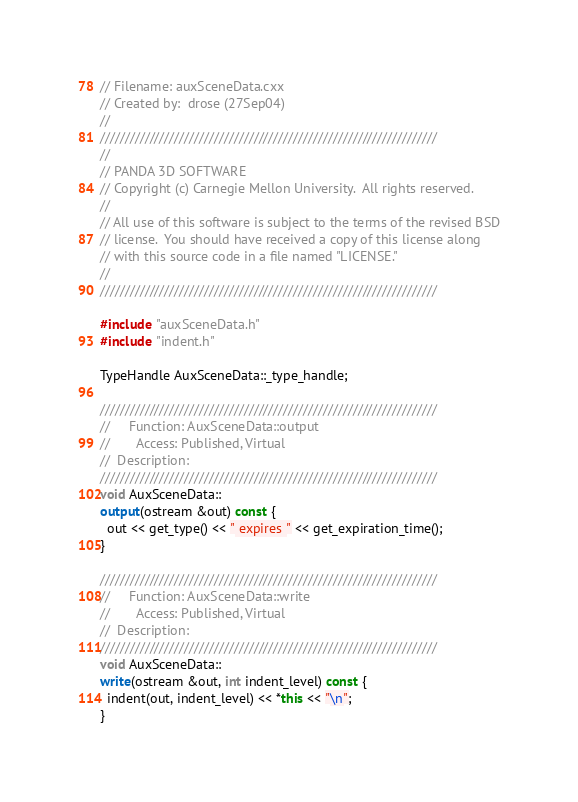<code> <loc_0><loc_0><loc_500><loc_500><_C++_>// Filename: auxSceneData.cxx
// Created by:  drose (27Sep04)
//
////////////////////////////////////////////////////////////////////
//
// PANDA 3D SOFTWARE
// Copyright (c) Carnegie Mellon University.  All rights reserved.
//
// All use of this software is subject to the terms of the revised BSD
// license.  You should have received a copy of this license along
// with this source code in a file named "LICENSE."
//
////////////////////////////////////////////////////////////////////

#include "auxSceneData.h"
#include "indent.h"

TypeHandle AuxSceneData::_type_handle;

////////////////////////////////////////////////////////////////////
//     Function: AuxSceneData::output
//       Access: Published, Virtual
//  Description: 
////////////////////////////////////////////////////////////////////
void AuxSceneData::
output(ostream &out) const {
  out << get_type() << " expires " << get_expiration_time();
}

////////////////////////////////////////////////////////////////////
//     Function: AuxSceneData::write
//       Access: Published, Virtual
//  Description: 
////////////////////////////////////////////////////////////////////
void AuxSceneData::
write(ostream &out, int indent_level) const {
  indent(out, indent_level) << *this << "\n";
}
</code> 